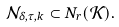<formula> <loc_0><loc_0><loc_500><loc_500>\mathcal { N } _ { \delta , \tau , k } \subset N _ { r } ( \mathcal { K } ) .</formula> 